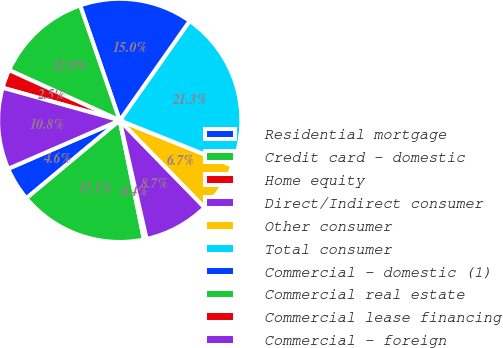Convert chart. <chart><loc_0><loc_0><loc_500><loc_500><pie_chart><fcel>Residential mortgage<fcel>Credit card - domestic<fcel>Home equity<fcel>Direct/Indirect consumer<fcel>Other consumer<fcel>Total consumer<fcel>Commercial - domestic (1)<fcel>Commercial real estate<fcel>Commercial lease financing<fcel>Commercial - foreign<nl><fcel>4.55%<fcel>17.12%<fcel>0.36%<fcel>8.74%<fcel>6.65%<fcel>21.31%<fcel>15.03%<fcel>12.93%<fcel>2.46%<fcel>10.84%<nl></chart> 